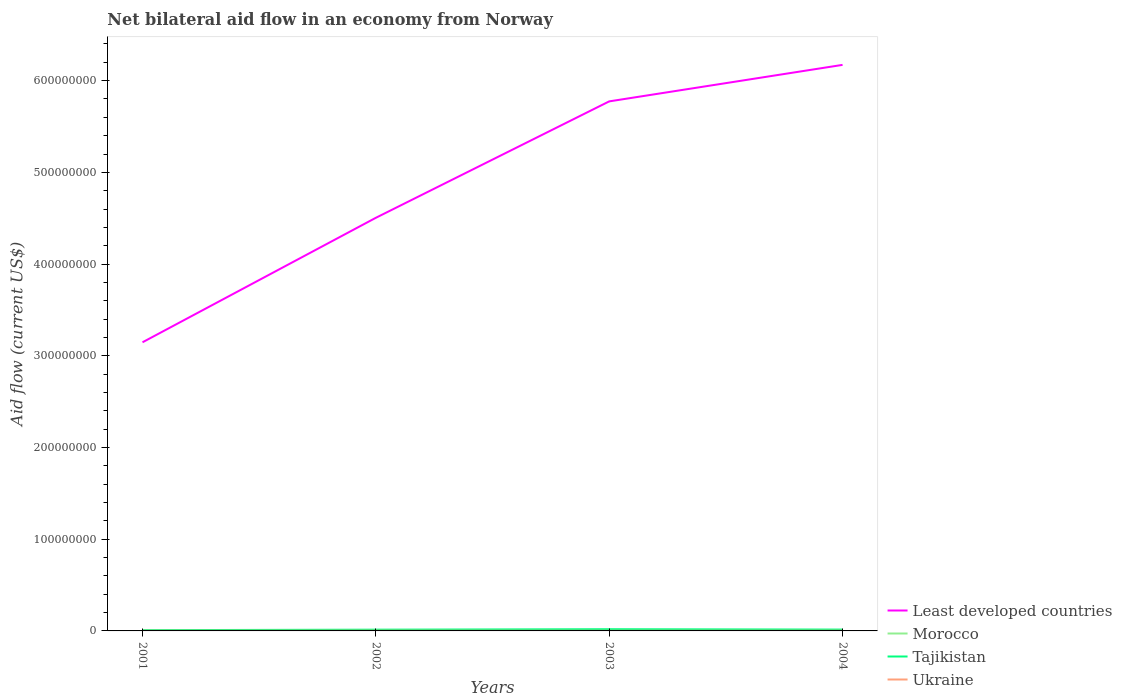Is the number of lines equal to the number of legend labels?
Your answer should be compact. Yes. Across all years, what is the maximum net bilateral aid flow in Tajikistan?
Make the answer very short. 8.30e+05. What is the difference between the highest and the second highest net bilateral aid flow in Tajikistan?
Your answer should be compact. 1.02e+06. How many years are there in the graph?
Keep it short and to the point. 4. What is the difference between two consecutive major ticks on the Y-axis?
Your answer should be very brief. 1.00e+08. Are the values on the major ticks of Y-axis written in scientific E-notation?
Offer a very short reply. No. How many legend labels are there?
Provide a short and direct response. 4. How are the legend labels stacked?
Provide a succinct answer. Vertical. What is the title of the graph?
Offer a very short reply. Net bilateral aid flow in an economy from Norway. What is the Aid flow (current US$) in Least developed countries in 2001?
Ensure brevity in your answer.  3.15e+08. What is the Aid flow (current US$) in Morocco in 2001?
Offer a very short reply. 9.00e+04. What is the Aid flow (current US$) of Tajikistan in 2001?
Keep it short and to the point. 8.30e+05. What is the Aid flow (current US$) of Ukraine in 2001?
Keep it short and to the point. 1.70e+05. What is the Aid flow (current US$) in Least developed countries in 2002?
Offer a terse response. 4.50e+08. What is the Aid flow (current US$) in Morocco in 2002?
Offer a terse response. 1.70e+05. What is the Aid flow (current US$) of Tajikistan in 2002?
Provide a succinct answer. 1.36e+06. What is the Aid flow (current US$) in Least developed countries in 2003?
Give a very brief answer. 5.77e+08. What is the Aid flow (current US$) in Morocco in 2003?
Ensure brevity in your answer.  3.60e+05. What is the Aid flow (current US$) of Tajikistan in 2003?
Your response must be concise. 1.85e+06. What is the Aid flow (current US$) of Ukraine in 2003?
Provide a short and direct response. 1.60e+05. What is the Aid flow (current US$) of Least developed countries in 2004?
Provide a succinct answer. 6.17e+08. What is the Aid flow (current US$) in Morocco in 2004?
Offer a very short reply. 8.30e+05. What is the Aid flow (current US$) of Tajikistan in 2004?
Your response must be concise. 1.47e+06. What is the Aid flow (current US$) of Ukraine in 2004?
Give a very brief answer. 2.20e+05. Across all years, what is the maximum Aid flow (current US$) of Least developed countries?
Your answer should be very brief. 6.17e+08. Across all years, what is the maximum Aid flow (current US$) in Morocco?
Keep it short and to the point. 8.30e+05. Across all years, what is the maximum Aid flow (current US$) of Tajikistan?
Give a very brief answer. 1.85e+06. Across all years, what is the minimum Aid flow (current US$) in Least developed countries?
Offer a terse response. 3.15e+08. Across all years, what is the minimum Aid flow (current US$) of Tajikistan?
Offer a very short reply. 8.30e+05. What is the total Aid flow (current US$) in Least developed countries in the graph?
Offer a terse response. 1.96e+09. What is the total Aid flow (current US$) of Morocco in the graph?
Your answer should be very brief. 1.45e+06. What is the total Aid flow (current US$) of Tajikistan in the graph?
Ensure brevity in your answer.  5.51e+06. What is the total Aid flow (current US$) of Ukraine in the graph?
Ensure brevity in your answer.  7.80e+05. What is the difference between the Aid flow (current US$) in Least developed countries in 2001 and that in 2002?
Ensure brevity in your answer.  -1.36e+08. What is the difference between the Aid flow (current US$) in Morocco in 2001 and that in 2002?
Make the answer very short. -8.00e+04. What is the difference between the Aid flow (current US$) of Tajikistan in 2001 and that in 2002?
Ensure brevity in your answer.  -5.30e+05. What is the difference between the Aid flow (current US$) of Least developed countries in 2001 and that in 2003?
Ensure brevity in your answer.  -2.63e+08. What is the difference between the Aid flow (current US$) in Morocco in 2001 and that in 2003?
Provide a short and direct response. -2.70e+05. What is the difference between the Aid flow (current US$) in Tajikistan in 2001 and that in 2003?
Provide a short and direct response. -1.02e+06. What is the difference between the Aid flow (current US$) in Ukraine in 2001 and that in 2003?
Your answer should be compact. 10000. What is the difference between the Aid flow (current US$) in Least developed countries in 2001 and that in 2004?
Keep it short and to the point. -3.02e+08. What is the difference between the Aid flow (current US$) in Morocco in 2001 and that in 2004?
Give a very brief answer. -7.40e+05. What is the difference between the Aid flow (current US$) of Tajikistan in 2001 and that in 2004?
Your response must be concise. -6.40e+05. What is the difference between the Aid flow (current US$) in Least developed countries in 2002 and that in 2003?
Your answer should be very brief. -1.27e+08. What is the difference between the Aid flow (current US$) of Morocco in 2002 and that in 2003?
Your answer should be very brief. -1.90e+05. What is the difference between the Aid flow (current US$) of Tajikistan in 2002 and that in 2003?
Provide a succinct answer. -4.90e+05. What is the difference between the Aid flow (current US$) of Least developed countries in 2002 and that in 2004?
Give a very brief answer. -1.67e+08. What is the difference between the Aid flow (current US$) in Morocco in 2002 and that in 2004?
Offer a terse response. -6.60e+05. What is the difference between the Aid flow (current US$) in Ukraine in 2002 and that in 2004?
Your answer should be compact. 10000. What is the difference between the Aid flow (current US$) in Least developed countries in 2003 and that in 2004?
Offer a very short reply. -3.98e+07. What is the difference between the Aid flow (current US$) of Morocco in 2003 and that in 2004?
Keep it short and to the point. -4.70e+05. What is the difference between the Aid flow (current US$) of Tajikistan in 2003 and that in 2004?
Your answer should be very brief. 3.80e+05. What is the difference between the Aid flow (current US$) in Least developed countries in 2001 and the Aid flow (current US$) in Morocco in 2002?
Provide a short and direct response. 3.15e+08. What is the difference between the Aid flow (current US$) in Least developed countries in 2001 and the Aid flow (current US$) in Tajikistan in 2002?
Your answer should be very brief. 3.13e+08. What is the difference between the Aid flow (current US$) in Least developed countries in 2001 and the Aid flow (current US$) in Ukraine in 2002?
Offer a very short reply. 3.14e+08. What is the difference between the Aid flow (current US$) of Morocco in 2001 and the Aid flow (current US$) of Tajikistan in 2002?
Your answer should be very brief. -1.27e+06. What is the difference between the Aid flow (current US$) of Morocco in 2001 and the Aid flow (current US$) of Ukraine in 2002?
Your response must be concise. -1.40e+05. What is the difference between the Aid flow (current US$) of Tajikistan in 2001 and the Aid flow (current US$) of Ukraine in 2002?
Your answer should be very brief. 6.00e+05. What is the difference between the Aid flow (current US$) of Least developed countries in 2001 and the Aid flow (current US$) of Morocco in 2003?
Provide a succinct answer. 3.14e+08. What is the difference between the Aid flow (current US$) in Least developed countries in 2001 and the Aid flow (current US$) in Tajikistan in 2003?
Provide a succinct answer. 3.13e+08. What is the difference between the Aid flow (current US$) of Least developed countries in 2001 and the Aid flow (current US$) of Ukraine in 2003?
Offer a very short reply. 3.15e+08. What is the difference between the Aid flow (current US$) of Morocco in 2001 and the Aid flow (current US$) of Tajikistan in 2003?
Ensure brevity in your answer.  -1.76e+06. What is the difference between the Aid flow (current US$) of Morocco in 2001 and the Aid flow (current US$) of Ukraine in 2003?
Provide a succinct answer. -7.00e+04. What is the difference between the Aid flow (current US$) in Tajikistan in 2001 and the Aid flow (current US$) in Ukraine in 2003?
Offer a terse response. 6.70e+05. What is the difference between the Aid flow (current US$) in Least developed countries in 2001 and the Aid flow (current US$) in Morocco in 2004?
Provide a short and direct response. 3.14e+08. What is the difference between the Aid flow (current US$) of Least developed countries in 2001 and the Aid flow (current US$) of Tajikistan in 2004?
Keep it short and to the point. 3.13e+08. What is the difference between the Aid flow (current US$) in Least developed countries in 2001 and the Aid flow (current US$) in Ukraine in 2004?
Ensure brevity in your answer.  3.14e+08. What is the difference between the Aid flow (current US$) of Morocco in 2001 and the Aid flow (current US$) of Tajikistan in 2004?
Offer a very short reply. -1.38e+06. What is the difference between the Aid flow (current US$) of Tajikistan in 2001 and the Aid flow (current US$) of Ukraine in 2004?
Offer a terse response. 6.10e+05. What is the difference between the Aid flow (current US$) of Least developed countries in 2002 and the Aid flow (current US$) of Morocco in 2003?
Offer a very short reply. 4.50e+08. What is the difference between the Aid flow (current US$) in Least developed countries in 2002 and the Aid flow (current US$) in Tajikistan in 2003?
Provide a succinct answer. 4.49e+08. What is the difference between the Aid flow (current US$) in Least developed countries in 2002 and the Aid flow (current US$) in Ukraine in 2003?
Offer a very short reply. 4.50e+08. What is the difference between the Aid flow (current US$) of Morocco in 2002 and the Aid flow (current US$) of Tajikistan in 2003?
Your answer should be very brief. -1.68e+06. What is the difference between the Aid flow (current US$) of Tajikistan in 2002 and the Aid flow (current US$) of Ukraine in 2003?
Offer a very short reply. 1.20e+06. What is the difference between the Aid flow (current US$) in Least developed countries in 2002 and the Aid flow (current US$) in Morocco in 2004?
Provide a short and direct response. 4.50e+08. What is the difference between the Aid flow (current US$) in Least developed countries in 2002 and the Aid flow (current US$) in Tajikistan in 2004?
Give a very brief answer. 4.49e+08. What is the difference between the Aid flow (current US$) of Least developed countries in 2002 and the Aid flow (current US$) of Ukraine in 2004?
Provide a succinct answer. 4.50e+08. What is the difference between the Aid flow (current US$) in Morocco in 2002 and the Aid flow (current US$) in Tajikistan in 2004?
Make the answer very short. -1.30e+06. What is the difference between the Aid flow (current US$) of Tajikistan in 2002 and the Aid flow (current US$) of Ukraine in 2004?
Provide a short and direct response. 1.14e+06. What is the difference between the Aid flow (current US$) in Least developed countries in 2003 and the Aid flow (current US$) in Morocco in 2004?
Offer a very short reply. 5.77e+08. What is the difference between the Aid flow (current US$) in Least developed countries in 2003 and the Aid flow (current US$) in Tajikistan in 2004?
Your response must be concise. 5.76e+08. What is the difference between the Aid flow (current US$) in Least developed countries in 2003 and the Aid flow (current US$) in Ukraine in 2004?
Give a very brief answer. 5.77e+08. What is the difference between the Aid flow (current US$) in Morocco in 2003 and the Aid flow (current US$) in Tajikistan in 2004?
Make the answer very short. -1.11e+06. What is the difference between the Aid flow (current US$) in Tajikistan in 2003 and the Aid flow (current US$) in Ukraine in 2004?
Your answer should be very brief. 1.63e+06. What is the average Aid flow (current US$) of Least developed countries per year?
Keep it short and to the point. 4.90e+08. What is the average Aid flow (current US$) of Morocco per year?
Keep it short and to the point. 3.62e+05. What is the average Aid flow (current US$) of Tajikistan per year?
Offer a very short reply. 1.38e+06. What is the average Aid flow (current US$) of Ukraine per year?
Give a very brief answer. 1.95e+05. In the year 2001, what is the difference between the Aid flow (current US$) in Least developed countries and Aid flow (current US$) in Morocco?
Offer a terse response. 3.15e+08. In the year 2001, what is the difference between the Aid flow (current US$) of Least developed countries and Aid flow (current US$) of Tajikistan?
Your response must be concise. 3.14e+08. In the year 2001, what is the difference between the Aid flow (current US$) in Least developed countries and Aid flow (current US$) in Ukraine?
Ensure brevity in your answer.  3.15e+08. In the year 2001, what is the difference between the Aid flow (current US$) of Morocco and Aid flow (current US$) of Tajikistan?
Provide a succinct answer. -7.40e+05. In the year 2002, what is the difference between the Aid flow (current US$) of Least developed countries and Aid flow (current US$) of Morocco?
Your answer should be compact. 4.50e+08. In the year 2002, what is the difference between the Aid flow (current US$) of Least developed countries and Aid flow (current US$) of Tajikistan?
Make the answer very short. 4.49e+08. In the year 2002, what is the difference between the Aid flow (current US$) in Least developed countries and Aid flow (current US$) in Ukraine?
Make the answer very short. 4.50e+08. In the year 2002, what is the difference between the Aid flow (current US$) in Morocco and Aid flow (current US$) in Tajikistan?
Your answer should be very brief. -1.19e+06. In the year 2002, what is the difference between the Aid flow (current US$) of Tajikistan and Aid flow (current US$) of Ukraine?
Give a very brief answer. 1.13e+06. In the year 2003, what is the difference between the Aid flow (current US$) of Least developed countries and Aid flow (current US$) of Morocco?
Your answer should be very brief. 5.77e+08. In the year 2003, what is the difference between the Aid flow (current US$) of Least developed countries and Aid flow (current US$) of Tajikistan?
Offer a very short reply. 5.76e+08. In the year 2003, what is the difference between the Aid flow (current US$) in Least developed countries and Aid flow (current US$) in Ukraine?
Give a very brief answer. 5.77e+08. In the year 2003, what is the difference between the Aid flow (current US$) in Morocco and Aid flow (current US$) in Tajikistan?
Provide a short and direct response. -1.49e+06. In the year 2003, what is the difference between the Aid flow (current US$) of Morocco and Aid flow (current US$) of Ukraine?
Keep it short and to the point. 2.00e+05. In the year 2003, what is the difference between the Aid flow (current US$) of Tajikistan and Aid flow (current US$) of Ukraine?
Ensure brevity in your answer.  1.69e+06. In the year 2004, what is the difference between the Aid flow (current US$) in Least developed countries and Aid flow (current US$) in Morocco?
Provide a short and direct response. 6.16e+08. In the year 2004, what is the difference between the Aid flow (current US$) in Least developed countries and Aid flow (current US$) in Tajikistan?
Your response must be concise. 6.16e+08. In the year 2004, what is the difference between the Aid flow (current US$) in Least developed countries and Aid flow (current US$) in Ukraine?
Provide a short and direct response. 6.17e+08. In the year 2004, what is the difference between the Aid flow (current US$) in Morocco and Aid flow (current US$) in Tajikistan?
Your response must be concise. -6.40e+05. In the year 2004, what is the difference between the Aid flow (current US$) in Morocco and Aid flow (current US$) in Ukraine?
Make the answer very short. 6.10e+05. In the year 2004, what is the difference between the Aid flow (current US$) of Tajikistan and Aid flow (current US$) of Ukraine?
Give a very brief answer. 1.25e+06. What is the ratio of the Aid flow (current US$) of Least developed countries in 2001 to that in 2002?
Your answer should be compact. 0.7. What is the ratio of the Aid flow (current US$) of Morocco in 2001 to that in 2002?
Make the answer very short. 0.53. What is the ratio of the Aid flow (current US$) in Tajikistan in 2001 to that in 2002?
Offer a very short reply. 0.61. What is the ratio of the Aid flow (current US$) of Ukraine in 2001 to that in 2002?
Give a very brief answer. 0.74. What is the ratio of the Aid flow (current US$) of Least developed countries in 2001 to that in 2003?
Offer a very short reply. 0.55. What is the ratio of the Aid flow (current US$) in Morocco in 2001 to that in 2003?
Provide a short and direct response. 0.25. What is the ratio of the Aid flow (current US$) in Tajikistan in 2001 to that in 2003?
Keep it short and to the point. 0.45. What is the ratio of the Aid flow (current US$) in Least developed countries in 2001 to that in 2004?
Ensure brevity in your answer.  0.51. What is the ratio of the Aid flow (current US$) of Morocco in 2001 to that in 2004?
Ensure brevity in your answer.  0.11. What is the ratio of the Aid flow (current US$) of Tajikistan in 2001 to that in 2004?
Provide a short and direct response. 0.56. What is the ratio of the Aid flow (current US$) in Ukraine in 2001 to that in 2004?
Give a very brief answer. 0.77. What is the ratio of the Aid flow (current US$) in Least developed countries in 2002 to that in 2003?
Give a very brief answer. 0.78. What is the ratio of the Aid flow (current US$) of Morocco in 2002 to that in 2003?
Offer a terse response. 0.47. What is the ratio of the Aid flow (current US$) in Tajikistan in 2002 to that in 2003?
Offer a terse response. 0.74. What is the ratio of the Aid flow (current US$) in Ukraine in 2002 to that in 2003?
Offer a very short reply. 1.44. What is the ratio of the Aid flow (current US$) in Least developed countries in 2002 to that in 2004?
Your answer should be very brief. 0.73. What is the ratio of the Aid flow (current US$) in Morocco in 2002 to that in 2004?
Offer a terse response. 0.2. What is the ratio of the Aid flow (current US$) of Tajikistan in 2002 to that in 2004?
Provide a short and direct response. 0.93. What is the ratio of the Aid flow (current US$) in Ukraine in 2002 to that in 2004?
Provide a short and direct response. 1.05. What is the ratio of the Aid flow (current US$) in Least developed countries in 2003 to that in 2004?
Your answer should be very brief. 0.94. What is the ratio of the Aid flow (current US$) of Morocco in 2003 to that in 2004?
Make the answer very short. 0.43. What is the ratio of the Aid flow (current US$) in Tajikistan in 2003 to that in 2004?
Keep it short and to the point. 1.26. What is the ratio of the Aid flow (current US$) in Ukraine in 2003 to that in 2004?
Make the answer very short. 0.73. What is the difference between the highest and the second highest Aid flow (current US$) of Least developed countries?
Ensure brevity in your answer.  3.98e+07. What is the difference between the highest and the second highest Aid flow (current US$) in Morocco?
Make the answer very short. 4.70e+05. What is the difference between the highest and the second highest Aid flow (current US$) of Tajikistan?
Provide a succinct answer. 3.80e+05. What is the difference between the highest and the second highest Aid flow (current US$) in Ukraine?
Make the answer very short. 10000. What is the difference between the highest and the lowest Aid flow (current US$) of Least developed countries?
Offer a terse response. 3.02e+08. What is the difference between the highest and the lowest Aid flow (current US$) in Morocco?
Ensure brevity in your answer.  7.40e+05. What is the difference between the highest and the lowest Aid flow (current US$) in Tajikistan?
Your answer should be very brief. 1.02e+06. 